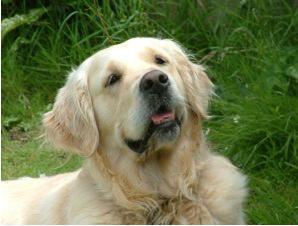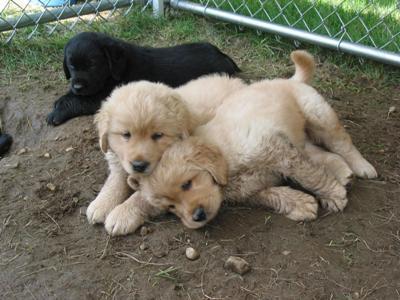The first image is the image on the left, the second image is the image on the right. Considering the images on both sides, is "One of the images shows exactly three puppies." valid? Answer yes or no. Yes. The first image is the image on the left, the second image is the image on the right. For the images displayed, is the sentence "An image shows two beige pups and one black pup." factually correct? Answer yes or no. Yes. 